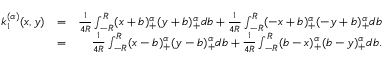<formula> <loc_0><loc_0><loc_500><loc_500>\begin{array} { r l r } { k _ { 1 } ^ { ( \alpha ) } ( x , y ) } & { = } & { \frac { 1 } { 4 R } \int _ { - R } ^ { R } ( x + b ) _ { + } ^ { \alpha } ( y + b ) _ { + } ^ { \alpha } d b + \frac { 1 } { 4 R } \int _ { - R } ^ { R } ( - x + b ) _ { + } ^ { \alpha } ( - y + b ) _ { + } ^ { \alpha } d b } \\ & { = } & { \frac { 1 } { 4 R } \int _ { - R } ^ { R } ( x - b ) _ { + } ^ { \alpha } ( y - b ) _ { + } ^ { \alpha } d b + \frac { 1 } { 4 R } \int _ { - R } ^ { R } ( b - x ) _ { + } ^ { \alpha } ( b - y ) _ { + } ^ { \alpha } d b . } \end{array}</formula> 